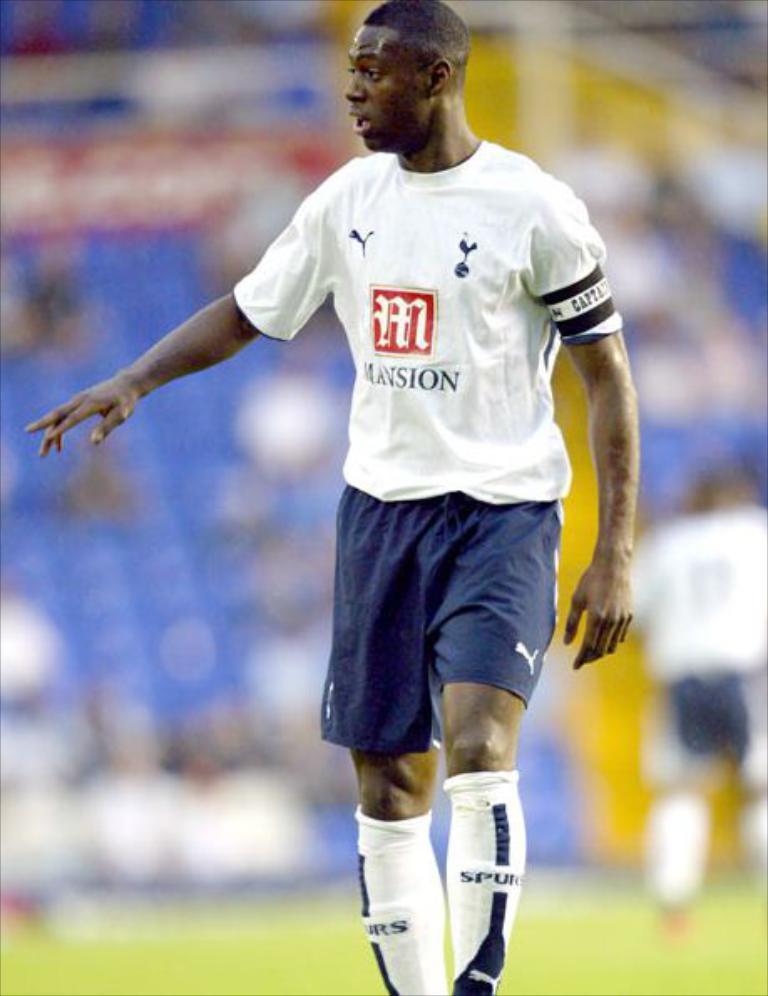How would you summarize this image in a sentence or two? In this picture we can see the player wearing white t-shirt and blue shorts standing in the ground. Behind there is a blur background. 